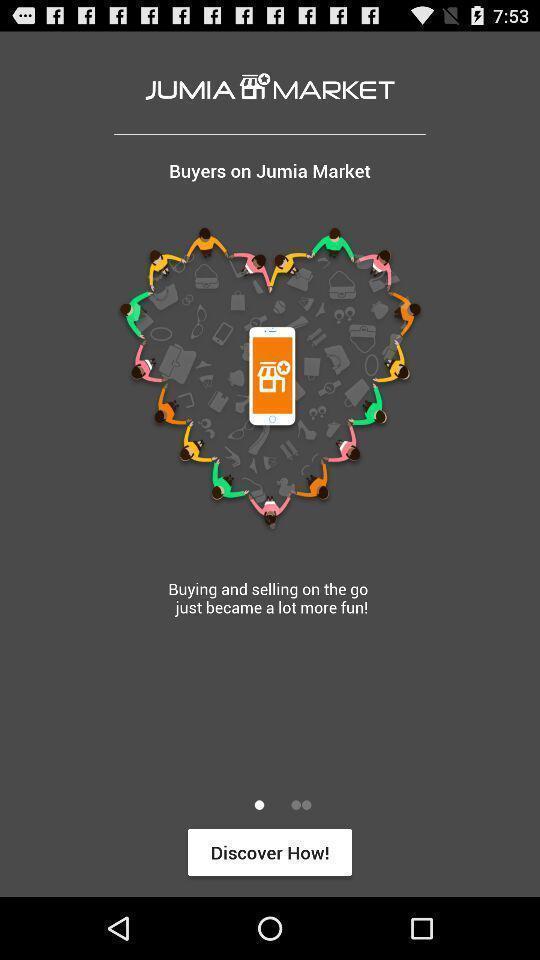Provide a textual representation of this image. Welcome page of an shopping application. 